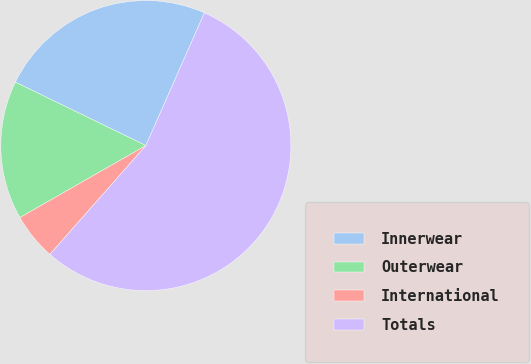Convert chart to OTSL. <chart><loc_0><loc_0><loc_500><loc_500><pie_chart><fcel>Innerwear<fcel>Outerwear<fcel>International<fcel>Totals<nl><fcel>24.41%<fcel>15.47%<fcel>5.23%<fcel>54.89%<nl></chart> 